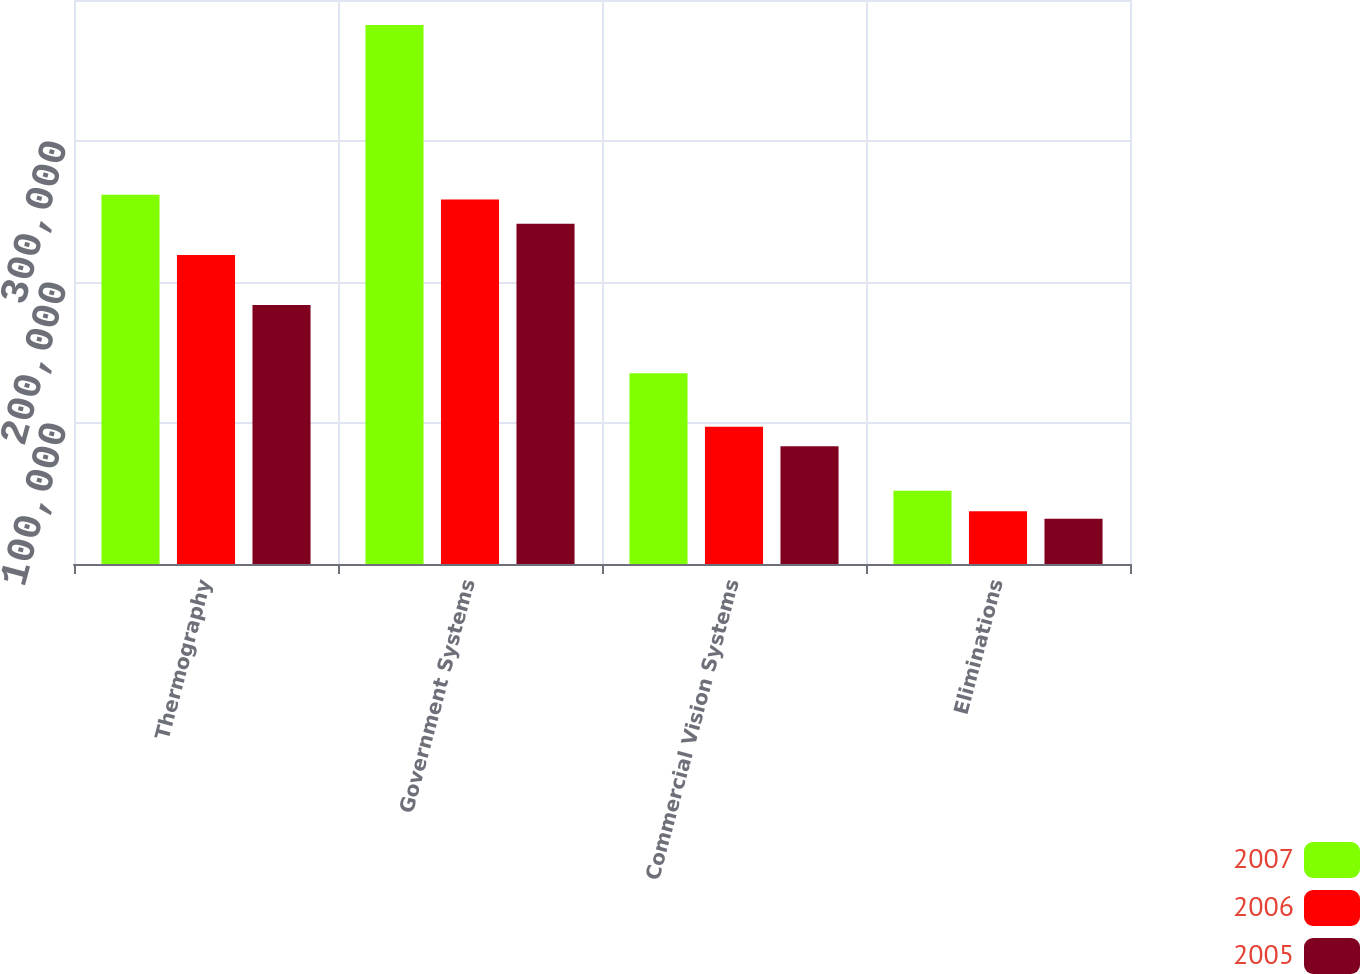Convert chart to OTSL. <chart><loc_0><loc_0><loc_500><loc_500><stacked_bar_chart><ecel><fcel>Thermography<fcel>Government Systems<fcel>Commercial Vision Systems<fcel>Eliminations<nl><fcel>2007<fcel>261831<fcel>382347<fcel>135219<fcel>51886<nl><fcel>2006<fcel>219218<fcel>258436<fcel>97346<fcel>37345<nl><fcel>2005<fcel>183606<fcel>241359<fcel>83596<fcel>32178<nl></chart> 